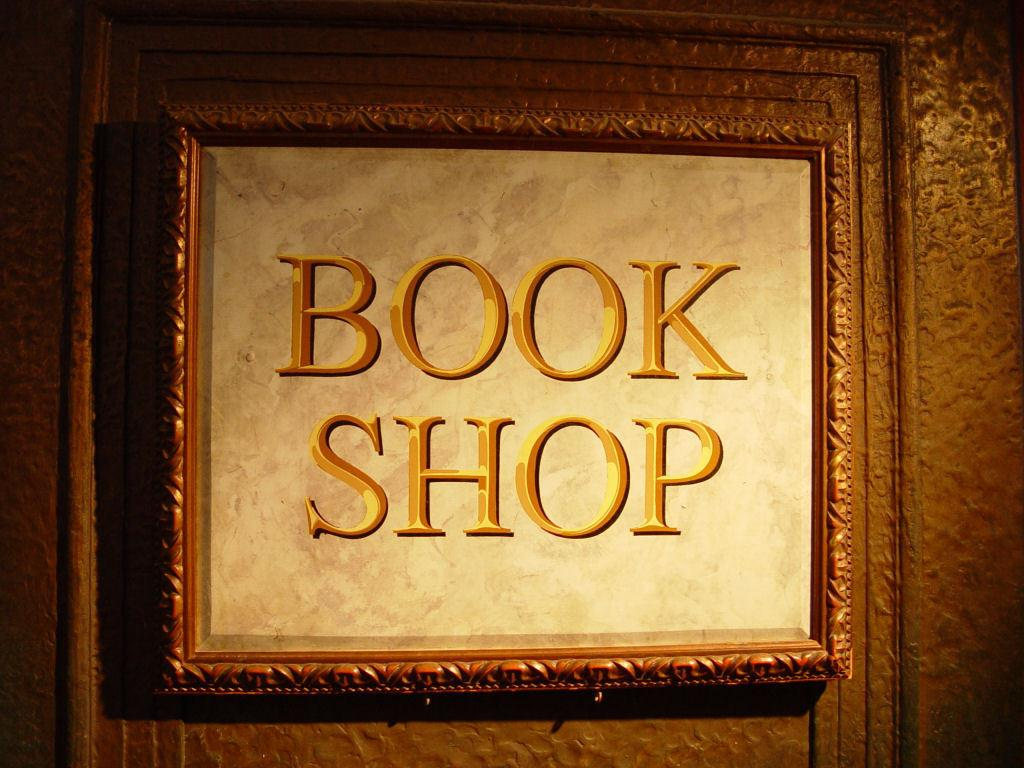<image>
Relay a brief, clear account of the picture shown. A framed poster has the words book shop written on it. 